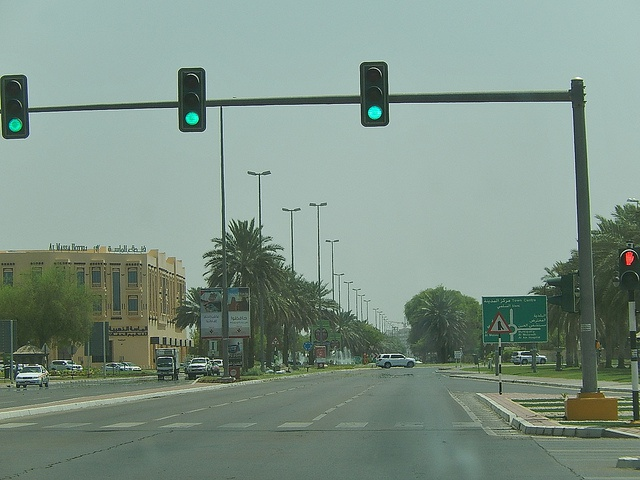Describe the objects in this image and their specific colors. I can see traffic light in darkgray, black, teal, and gray tones, traffic light in darkgray, black, darkgreen, teal, and gray tones, traffic light in darkgray, black, darkgreen, and teal tones, traffic light in darkgray, black, salmon, gray, and darkgreen tones, and truck in darkgray, black, gray, and darkgreen tones in this image. 